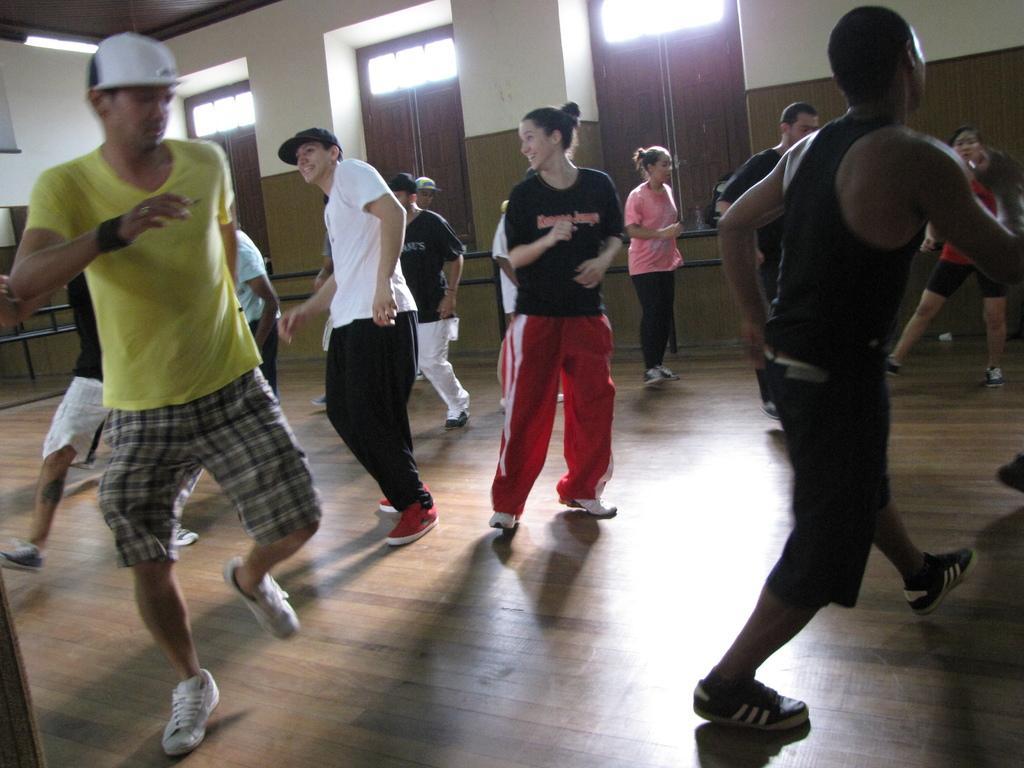How would you summarize this image in a sentence or two? There are many people dancing. Some are wearing caps. In the back there are windows and wall. On the ceiling there is light. 